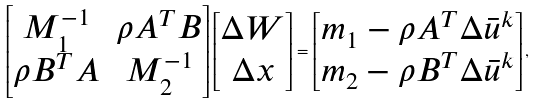Convert formula to latex. <formula><loc_0><loc_0><loc_500><loc_500>\begin{bmatrix} M _ { 1 } ^ { - 1 } & \rho A ^ { T } B \\ \rho B ^ { T } A & M _ { 2 } ^ { - 1 } \end{bmatrix} \begin{bmatrix} \Delta W \\ \Delta x \end{bmatrix} = \begin{bmatrix} m _ { 1 } - \rho A ^ { T } \Delta \bar { u } ^ { k } \\ m _ { 2 } - \rho B ^ { T } \Delta \bar { u } ^ { k } \end{bmatrix} ,</formula> 